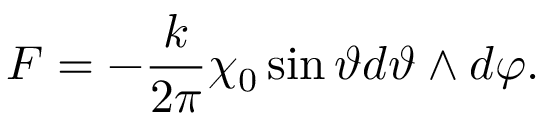Convert formula to latex. <formula><loc_0><loc_0><loc_500><loc_500>F = - \frac { k } { 2 \pi } \chi _ { 0 } \sin \vartheta d \vartheta \wedge d \varphi .</formula> 